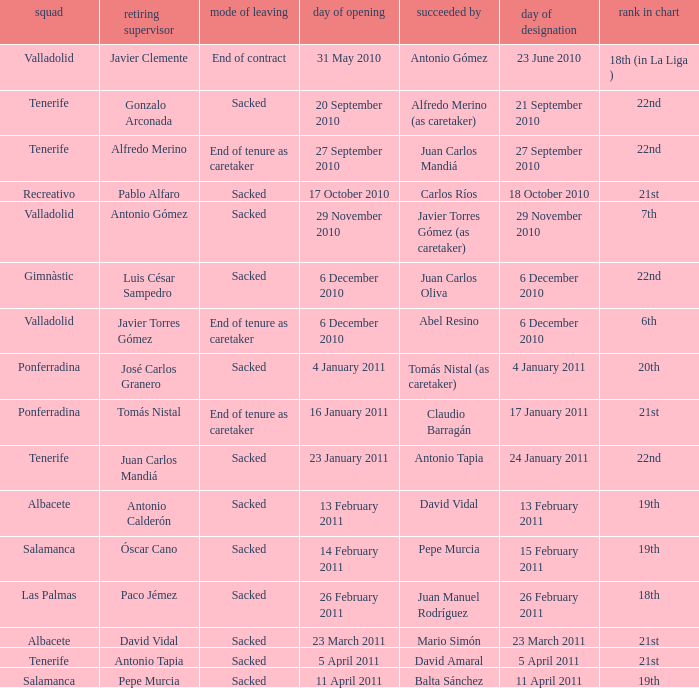Could you help me parse every detail presented in this table? {'header': ['squad', 'retiring supervisor', 'mode of leaving', 'day of opening', 'succeeded by', 'day of designation', 'rank in chart'], 'rows': [['Valladolid', 'Javier Clemente', 'End of contract', '31 May 2010', 'Antonio Gómez', '23 June 2010', '18th (in La Liga )'], ['Tenerife', 'Gonzalo Arconada', 'Sacked', '20 September 2010', 'Alfredo Merino (as caretaker)', '21 September 2010', '22nd'], ['Tenerife', 'Alfredo Merino', 'End of tenure as caretaker', '27 September 2010', 'Juan Carlos Mandiá', '27 September 2010', '22nd'], ['Recreativo', 'Pablo Alfaro', 'Sacked', '17 October 2010', 'Carlos Ríos', '18 October 2010', '21st'], ['Valladolid', 'Antonio Gómez', 'Sacked', '29 November 2010', 'Javier Torres Gómez (as caretaker)', '29 November 2010', '7th'], ['Gimnàstic', 'Luis César Sampedro', 'Sacked', '6 December 2010', 'Juan Carlos Oliva', '6 December 2010', '22nd'], ['Valladolid', 'Javier Torres Gómez', 'End of tenure as caretaker', '6 December 2010', 'Abel Resino', '6 December 2010', '6th'], ['Ponferradina', 'José Carlos Granero', 'Sacked', '4 January 2011', 'Tomás Nistal (as caretaker)', '4 January 2011', '20th'], ['Ponferradina', 'Tomás Nistal', 'End of tenure as caretaker', '16 January 2011', 'Claudio Barragán', '17 January 2011', '21st'], ['Tenerife', 'Juan Carlos Mandiá', 'Sacked', '23 January 2011', 'Antonio Tapia', '24 January 2011', '22nd'], ['Albacete', 'Antonio Calderón', 'Sacked', '13 February 2011', 'David Vidal', '13 February 2011', '19th'], ['Salamanca', 'Óscar Cano', 'Sacked', '14 February 2011', 'Pepe Murcia', '15 February 2011', '19th'], ['Las Palmas', 'Paco Jémez', 'Sacked', '26 February 2011', 'Juan Manuel Rodríguez', '26 February 2011', '18th'], ['Albacete', 'David Vidal', 'Sacked', '23 March 2011', 'Mario Simón', '23 March 2011', '21st'], ['Tenerife', 'Antonio Tapia', 'Sacked', '5 April 2011', 'David Amaral', '5 April 2011', '21st'], ['Salamanca', 'Pepe Murcia', 'Sacked', '11 April 2011', 'Balta Sánchez', '11 April 2011', '19th']]} What was the position of appointment date 17 january 2011 21st. 